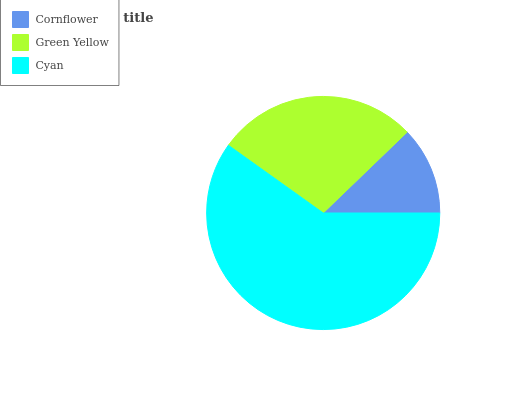Is Cornflower the minimum?
Answer yes or no. Yes. Is Cyan the maximum?
Answer yes or no. Yes. Is Green Yellow the minimum?
Answer yes or no. No. Is Green Yellow the maximum?
Answer yes or no. No. Is Green Yellow greater than Cornflower?
Answer yes or no. Yes. Is Cornflower less than Green Yellow?
Answer yes or no. Yes. Is Cornflower greater than Green Yellow?
Answer yes or no. No. Is Green Yellow less than Cornflower?
Answer yes or no. No. Is Green Yellow the high median?
Answer yes or no. Yes. Is Green Yellow the low median?
Answer yes or no. Yes. Is Cornflower the high median?
Answer yes or no. No. Is Cyan the low median?
Answer yes or no. No. 